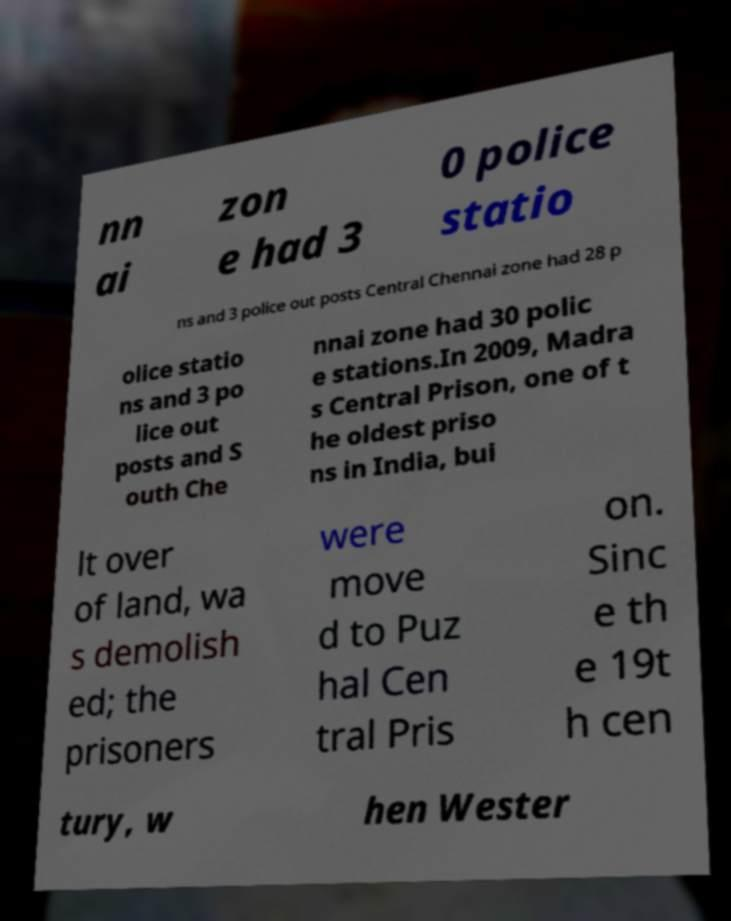Please read and relay the text visible in this image. What does it say? nn ai zon e had 3 0 police statio ns and 3 police out posts Central Chennai zone had 28 p olice statio ns and 3 po lice out posts and S outh Che nnai zone had 30 polic e stations.In 2009, Madra s Central Prison, one of t he oldest priso ns in India, bui lt over of land, wa s demolish ed; the prisoners were move d to Puz hal Cen tral Pris on. Sinc e th e 19t h cen tury, w hen Wester 